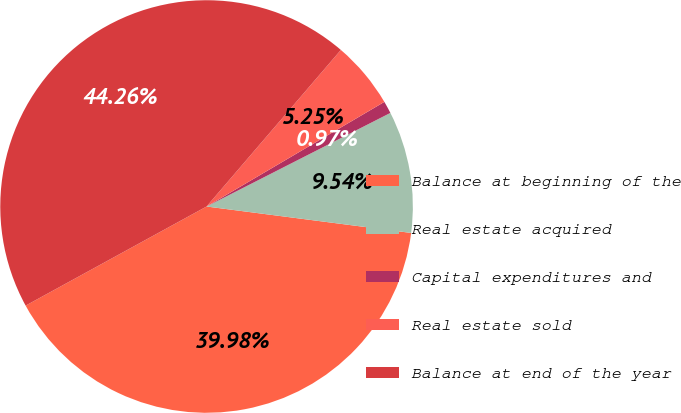<chart> <loc_0><loc_0><loc_500><loc_500><pie_chart><fcel>Balance at beginning of the<fcel>Real estate acquired<fcel>Capital expenditures and<fcel>Real estate sold<fcel>Balance at end of the year<nl><fcel>39.98%<fcel>9.54%<fcel>0.97%<fcel>5.25%<fcel>44.26%<nl></chart> 